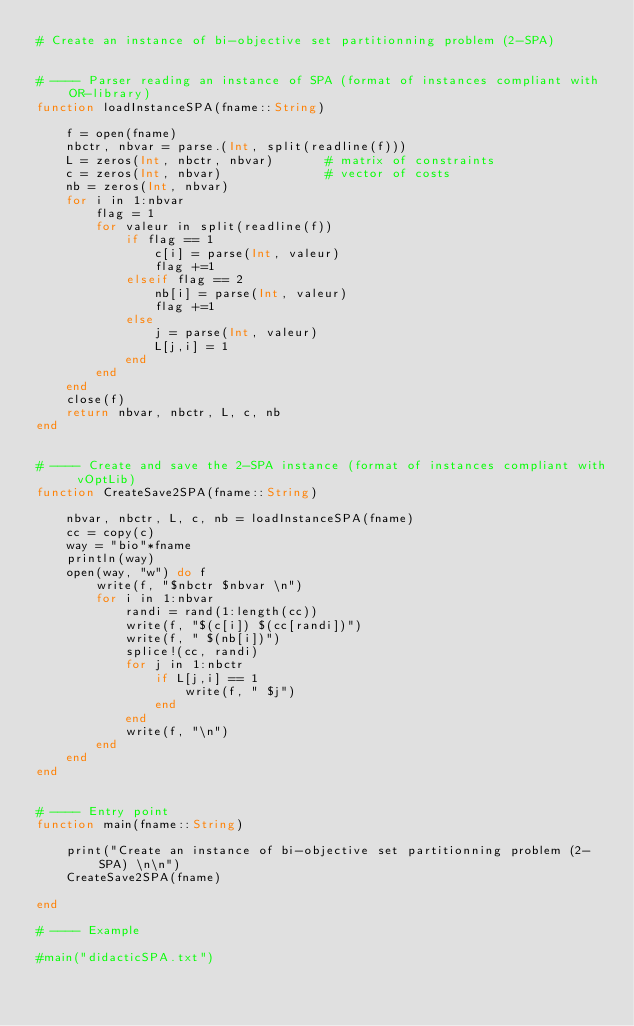<code> <loc_0><loc_0><loc_500><loc_500><_Julia_># Create an instance of bi-objective set partitionning problem (2-SPA)


# ---- Parser reading an instance of SPA (format of instances compliant with OR-library)
function loadInstanceSPA(fname::String)

    f = open(fname)
    nbctr, nbvar = parse.(Int, split(readline(f)))
    L = zeros(Int, nbctr, nbvar)       # matrix of constraints
    c = zeros(Int, nbvar)              # vector of costs
    nb = zeros(Int, nbvar)
    for i in 1:nbvar
        flag = 1
        for valeur in split(readline(f))
            if flag == 1
                c[i] = parse(Int, valeur)
                flag +=1
            elseif flag == 2
                nb[i] = parse(Int, valeur)
                flag +=1
            else
                j = parse(Int, valeur)
                L[j,i] = 1
            end
        end
    end
    close(f)
    return nbvar, nbctr, L, c, nb
end


# ---- Create and save the 2-SPA instance (format of instances compliant with vOptLib)
function CreateSave2SPA(fname::String)

    nbvar, nbctr, L, c, nb = loadInstanceSPA(fname)
    cc = copy(c)
    way = "bio"*fname
    println(way)
    open(way, "w") do f
        write(f, "$nbctr $nbvar \n")
        for i in 1:nbvar
            randi = rand(1:length(cc))
            write(f, "$(c[i]) $(cc[randi])")
            write(f, " $(nb[i])")
            splice!(cc, randi)
            for j in 1:nbctr
                if L[j,i] == 1
                    write(f, " $j")
                end
            end
            write(f, "\n")
        end
    end
end


# ---- Entry point
function main(fname::String)

    print("Create an instance of bi-objective set partitionning problem (2-SPA) \n\n")
    CreateSave2SPA(fname)

end

# ---- Example

#main("didacticSPA.txt")
</code> 